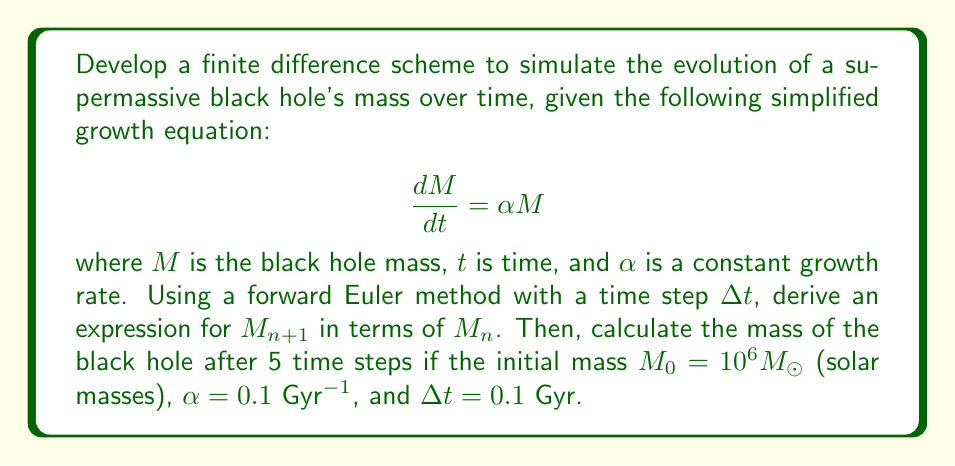Could you help me with this problem? To develop a finite difference scheme using the forward Euler method:

1) The forward Euler method approximates the derivative as:

   $$\frac{dM}{dt} \approx \frac{M_{n+1} - M_n}{\Delta t}$$

2) Substituting this into the given equation:

   $$\frac{M_{n+1} - M_n}{\Delta t} = \alpha M_n$$

3) Rearranging to solve for $M_{n+1}$:

   $$M_{n+1} = M_n + \alpha M_n \Delta t$$
   $$M_{n+1} = M_n(1 + \alpha \Delta t)$$

4) This is our finite difference scheme. To calculate the mass after 5 time steps:

   Initial values: $M_0 = 10^6 M_{\odot}$, $\alpha = 0.1$ Gyr$^{-1}$, $\Delta t = 0.1$ Gyr

5) Calculate $(1 + \alpha \Delta t)$:
   
   $1 + 0.1 \cdot 0.1 = 1.01$

6) Apply the scheme iteratively:

   $M_1 = 10^6 \cdot 1.01 = 1.01 \times 10^6 M_{\odot}$
   $M_2 = 1.01 \times 10^6 \cdot 1.01 = 1.0201 \times 10^6 M_{\odot}$
   $M_3 = 1.0201 \times 10^6 \cdot 1.01 = 1.030301 \times 10^6 M_{\odot}$
   $M_4 = 1.030301 \times 10^6 \cdot 1.01 = 1.04060401 \times 10^6 M_{\odot}$
   $M_5 = 1.04060401 \times 10^6 \cdot 1.01 = 1.0510100501 \times 10^6 M_{\odot}$

7) Therefore, after 5 time steps, the black hole mass is approximately $1.0510100501 \times 10^6 M_{\odot}$.
Answer: $1.0510100501 \times 10^6 M_{\odot}$ 